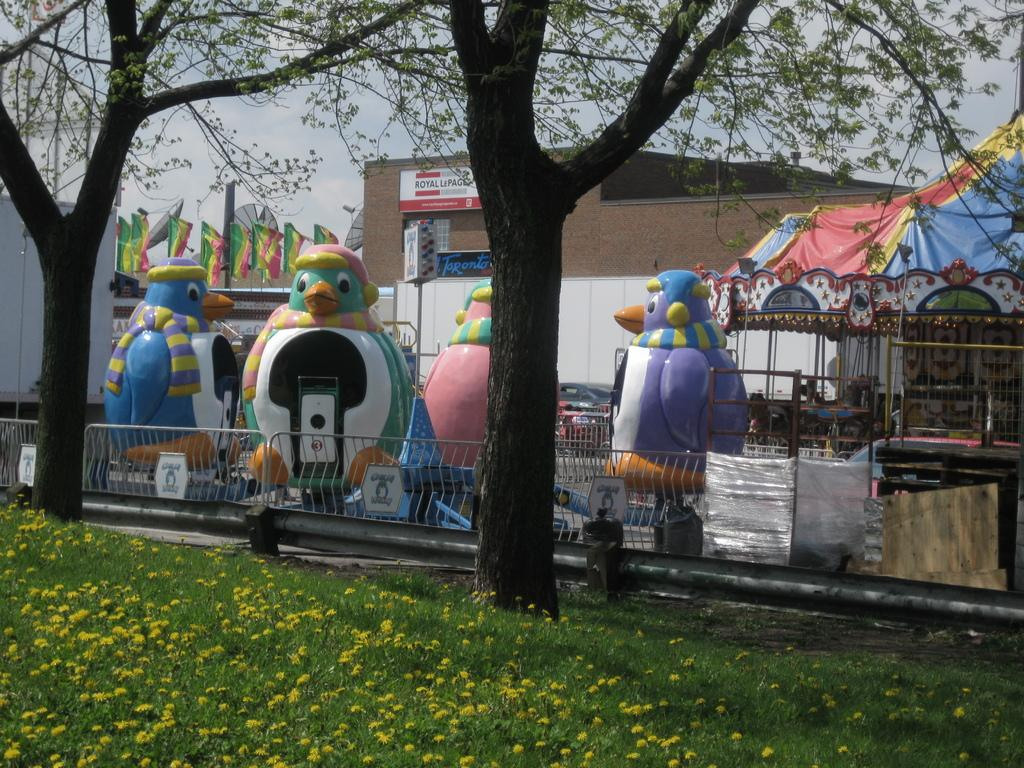What type of vegetation can be seen in the image? There is grass and trees in the image. What is visible in the background of the image? There is a building in the background of the image. Can you read any text in the image? Yes, there is text written on the building. Can you see a flock of birds flying in the image? There is no flock of birds visible in the image. Is the building in the image located in space? The image does not suggest that the building is located in space; it appears to be on Earth. 